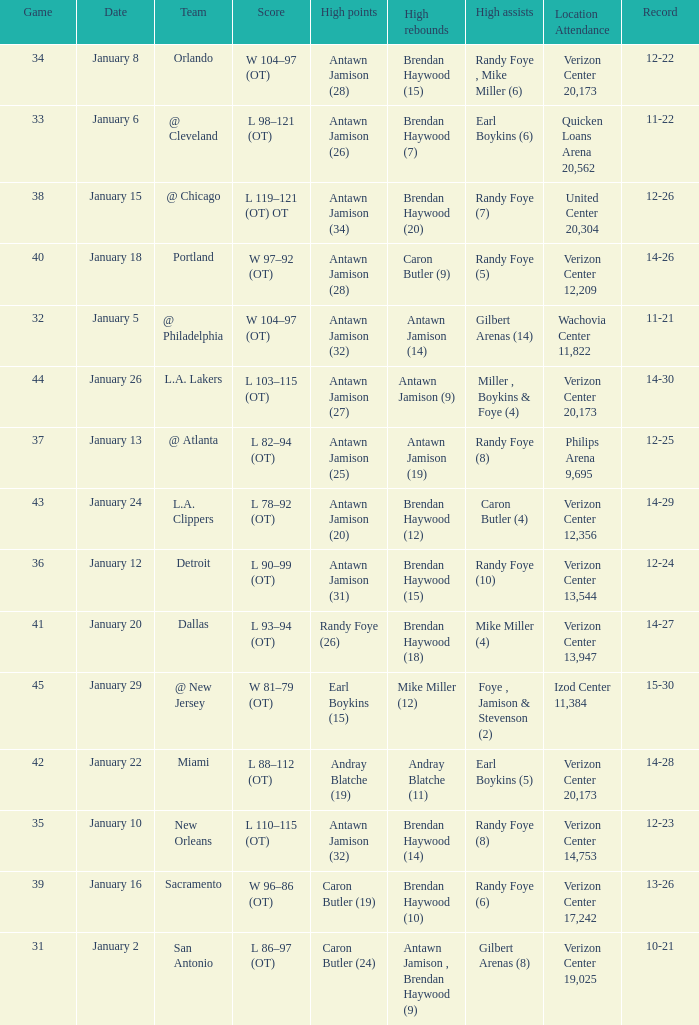What day was the record 14-27? January 20. 